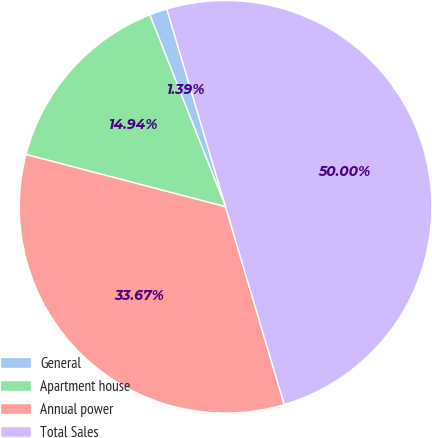<chart> <loc_0><loc_0><loc_500><loc_500><pie_chart><fcel>General<fcel>Apartment house<fcel>Annual power<fcel>Total Sales<nl><fcel>1.39%<fcel>14.94%<fcel>33.67%<fcel>50.0%<nl></chart> 